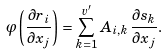<formula> <loc_0><loc_0><loc_500><loc_500>\varphi \left ( \frac { \partial r _ { i } } { \partial x _ { j } } \right ) = \sum _ { k = 1 } ^ { v ^ { \prime } } A _ { i , k } \, \frac { \partial s _ { k } } { \partial x _ { j } } .</formula> 